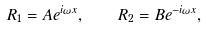<formula> <loc_0><loc_0><loc_500><loc_500>R _ { 1 } = A e ^ { i \omega x } , \quad R _ { 2 } = B e ^ { - i \omega x } ,</formula> 